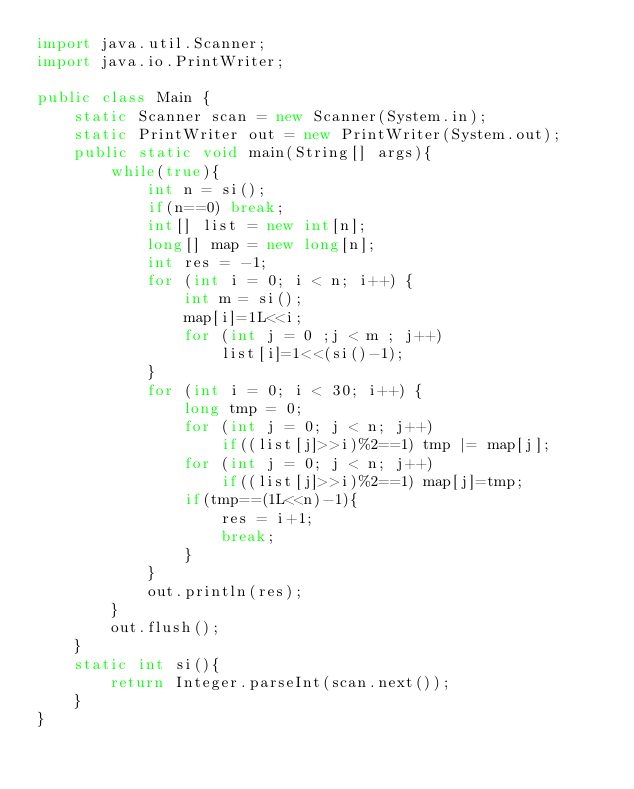<code> <loc_0><loc_0><loc_500><loc_500><_Java_>import java.util.Scanner;
import java.io.PrintWriter;
 
public class Main {
    static Scanner scan = new Scanner(System.in);
    static PrintWriter out = new PrintWriter(System.out);
    public static void main(String[] args){
        while(true){
            int n = si();
            if(n==0) break;
            int[] list = new int[n];
            long[] map = new long[n];
            int res = -1;
            for (int i = 0; i < n; i++) {
                int m = si();
                map[i]=1L<<i;
                for (int j = 0 ;j < m ; j++)
                    list[i]=1<<(si()-1);
            }
            for (int i = 0; i < 30; i++) {
                long tmp = 0;
                for (int j = 0; j < n; j++)
                    if((list[j]>>i)%2==1) tmp |= map[j];
                for (int j = 0; j < n; j++)
                    if((list[j]>>i)%2==1) map[j]=tmp;
                if(tmp==(1L<<n)-1){
                    res = i+1;
                    break;
                }
            }
            out.println(res);
        }
        out.flush();
    }
    static int si(){
        return Integer.parseInt(scan.next());
    }
}</code> 